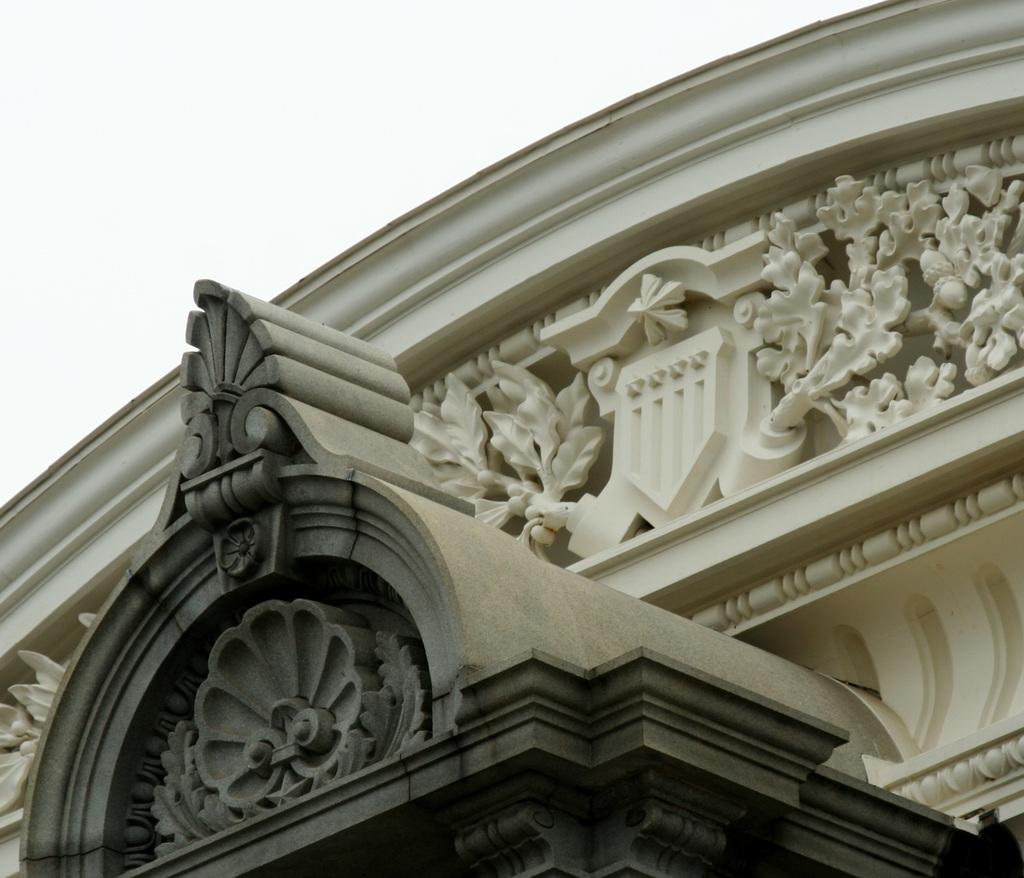What is the main subject of the image? The main subject of the image is a construction. Are there any specific features on the construction? Yes, the construction has sculptures on it. What is visible at the top of the image? The sky is visible at the top of the image. How many boys are managing the liquid in the image? There are no boys or liquid present in the image. 